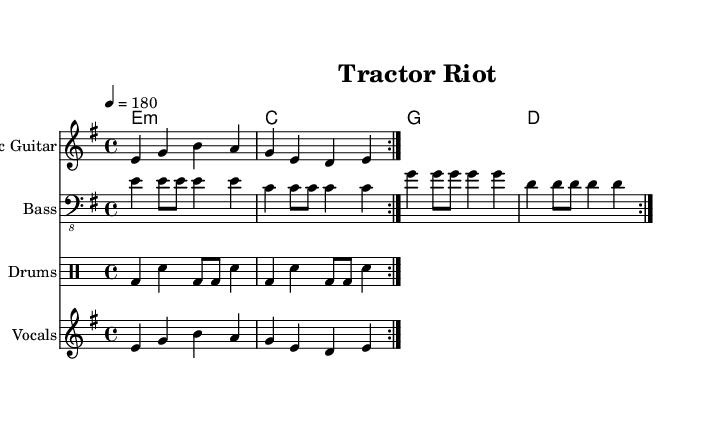What is the key signature of this music? The key signature is E minor, which contains one sharp (F#). This is determined by the "key e" indication in the global settings of the sheet music.
Answer: E minor What is the time signature of this music? The time signature is 4/4, indicating four beats per measure which is notated in the global settings.
Answer: 4/4 What is the tempo marking for this piece? The tempo marking is 180 beats per minute, as indicated by the "4 = 180" in the global settings. This specifies how fast the piece should be played.
Answer: 180 How many times is the main riff repeated? The main riff is repeated twice, as indicated by the "repeat volta 2" notation in both the electric guitar and vocals melody parts. This means both sections are played two times.
Answer: 2 What instruments are included in this score? The score includes an Electric Guitar, Bass, Drums, and Vocals. This can be confirmed by their respective staff names at the beginning of each part in the score.
Answer: Electric Guitar, Bass, Drums, Vocals What lyrical theme is presented in this song? The lyrical theme highlights rural life versus modernization, as indicated by lines addressing "fields of green" turned to "fields of steel," portraying a sense of rebellion against industrial change.
Answer: Rural rebellion against modernization What is the main chord progression used in the verse? The main chord progression in the verse is E minor, C, G, D, reflecting a common structure in punk music that supports the energetic and defiant vocals. This is notated in the chords section with their respective symbols.
Answer: E minor, C, G, D 